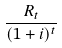<formula> <loc_0><loc_0><loc_500><loc_500>\frac { R _ { t } } { ( 1 + i ) ^ { t } }</formula> 